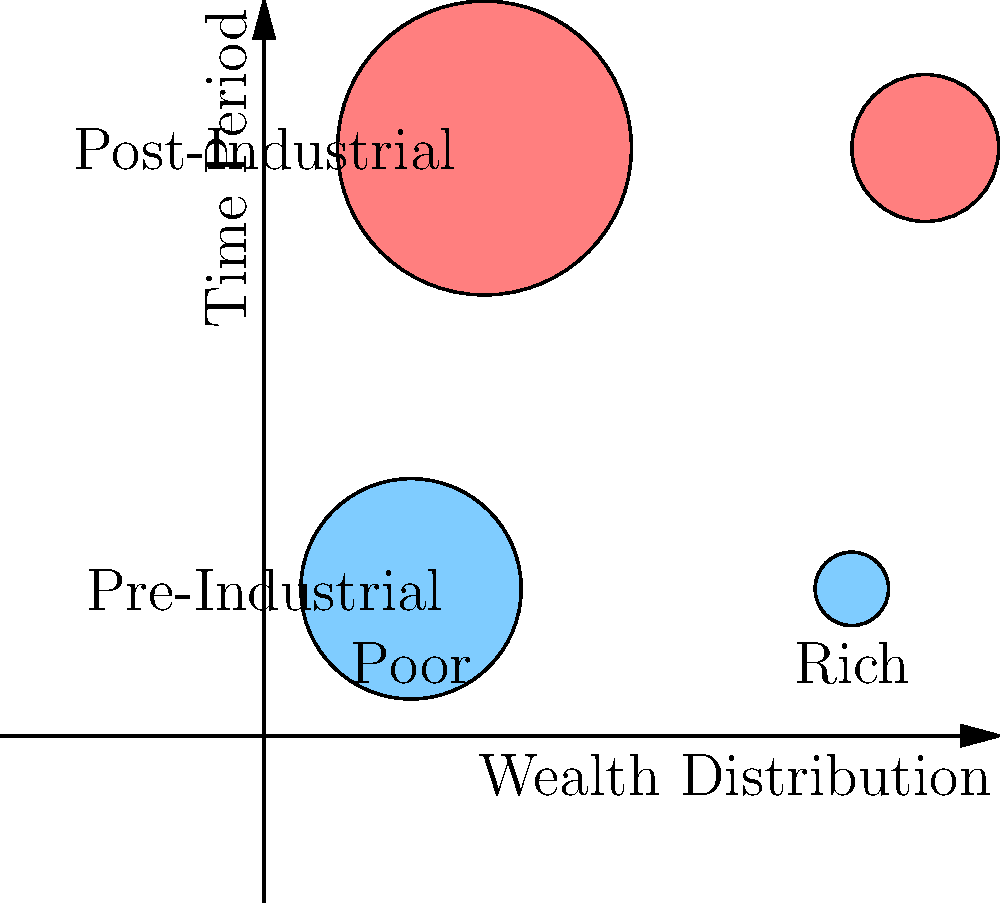Based on the bubble chart depicting wealth distribution before and after the Industrial Revolution, what significant change can be observed in the distribution of wealth between the poor and rich classes? To answer this question, let's analyze the bubble chart step-by-step:

1. The x-axis represents wealth distribution, with "Poor" on the left and "Rich" on the right.
2. The y-axis represents time periods, with "Pre-Industrial" at the bottom and "Post-Industrial" at the top.
3. The size of each bubble represents the relative wealth or population size of each group.

Pre-Industrial Era:
4. The blue bubble on the left (poor) is significantly larger than the blue bubble on the right (rich).
5. This indicates that before the Industrial Revolution, the majority of the population was poor, with a small wealthy class.

Post-Industrial Era:
6. The red bubble on the left (poor) is still larger than the red bubble on the right (rich).
7. However, the size difference between the poor and rich bubbles has decreased compared to the pre-industrial era.
8. The rich bubble has grown in size, while the poor bubble has slightly decreased.

Significant change:
9. The Industrial Revolution led to a more even distribution of wealth, with the gap between rich and poor narrowing.
10. The wealthy class grew in size and wealth, indicating the emergence of a larger middle class and more opportunities for wealth accumulation.

In conclusion, the most significant change observed is the reduction in wealth inequality, with a growing middle and upper class, while still maintaining a larger but relatively smaller poor population.
Answer: Reduced wealth inequality and growth of middle/upper classes 